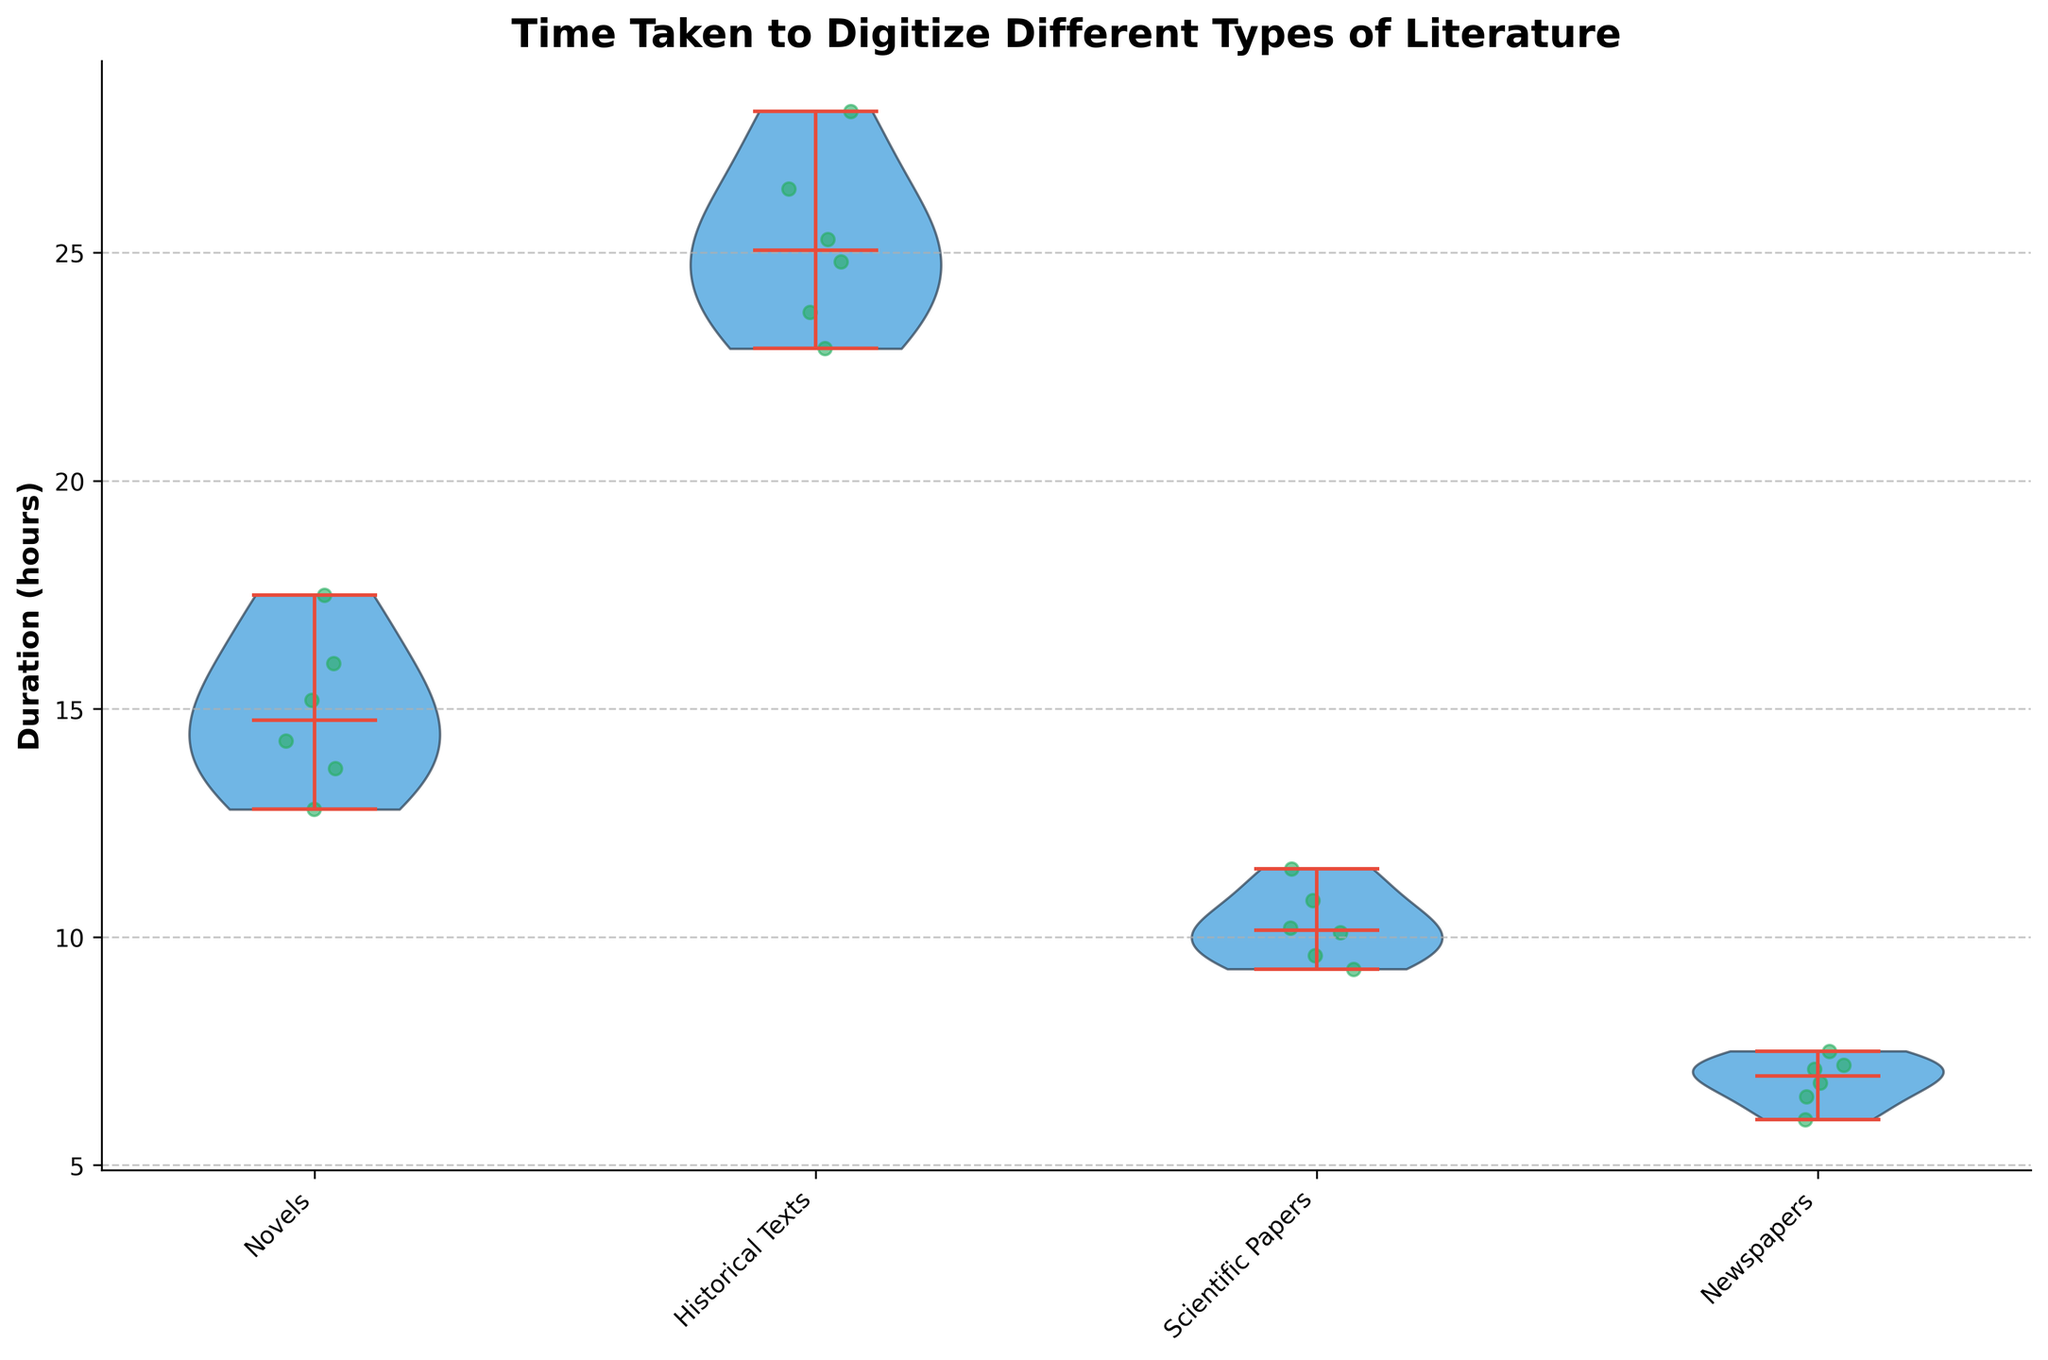What types of literature are included in the plot? The plot includes different types of literature, which are labeled on the x-axis: Novels, Historical Texts, Scientific Papers, and Newspapers. By looking at the x-axis labels, all the literature types can be identified.
Answer: Novels, Historical Texts, Scientific Papers, Newspapers Which type of literature has the longest digitization time on average? To find the type of literature with the longest average digitization time, you can look at the positions of the medians or mean dots on the y-axis. Historical Texts show a visibly higher median than any other type, indicating a longer average digitization time.
Answer: Historical Texts What is the median digitization time for Scientific Papers? The median for each literature type is indicated by a horizontal line within each violin plot. For Scientific Papers, this median line is around the 10.1-hour mark.
Answer: 10.1 hours Which type of literature has the smallest range of digitization times? The smallest range of digitization times can be identified by finding the narrowest spread from top to bottom of the violin shape. Newspapers show the most compact spread indicating the smallest range.
Answer: Newspapers Is the median time to digitize Historical Texts greater than the maximum time for Newspapers? To compare, observe the median line of Historical Texts and the top of the violin plot for Newspapers. The median for Historical Texts is above 24 hours, while the maximum for Newspapers is below 8 hours. Thus, the median of Historical Texts is indeed greater than the maximum of Newspapers.
Answer: Yes What are the approximate maximum and minimum times taken to digitize Novels? The maximum and minimum values for Novels can be observed at the top and bottom extent of the violin plot. For Novels, the maximum is slightly under 18 hours, and the minimum is around 12.5 hours.
Answer: Maximum: 17.5 hours, Minimum: 12.8 hours Is the variability of digitization times highest for Historical Texts or Novels? Variability can be inferred from the width of the violin plots. The violin plot for Historical Texts is wider than that for Novels, indicating higher variability.
Answer: Historical Texts Which category has the least dense distribution of digitization times? Look for the violin plot with the narrowest width indicating less density. Novels have broader sections within, particularly at the middle, suggesting a less dense distribution compared to others.
Answer: Novels How does the median digitization time for Scientific Papers compare to Newspapers? Compare the median lines of the violin plots for both categories. The median time for Scientific Papers is higher than for Newspapers, which is around 6.7 hours.
Answer: Greater than Newspapers 